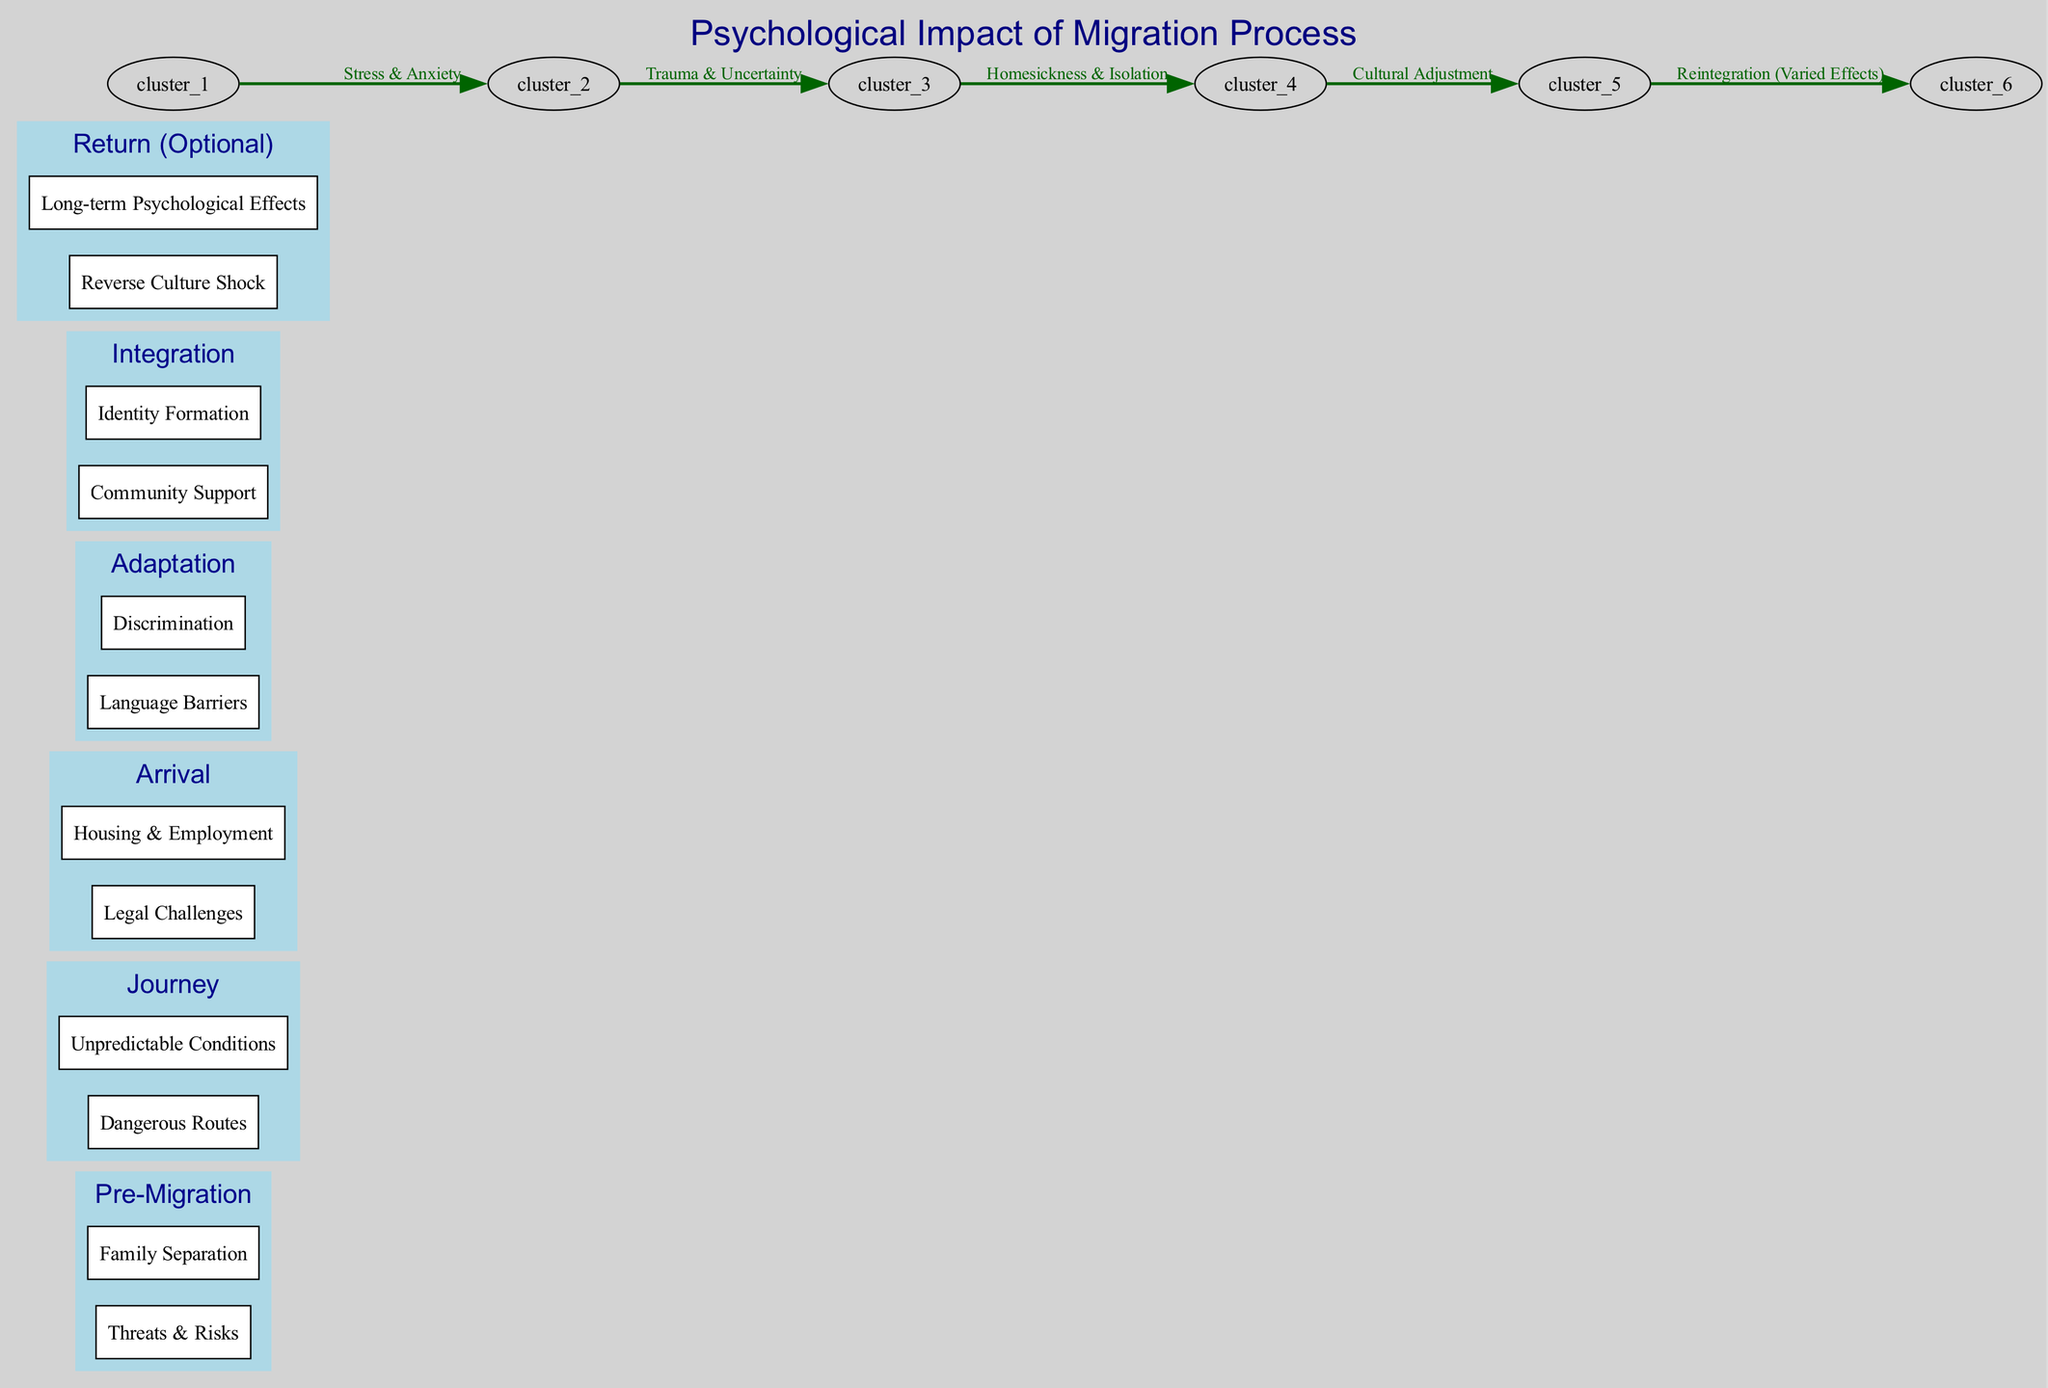What is the title of the diagram? The title is explicitly mentioned at the top of the diagram, which states "Psychological Impact of Migration Process."
Answer: Psychological Impact of Migration Process How many main nodes are in the diagram? By counting the distinct nodes listed in the "nodes" section of the data, there are six main nodes: Pre-Migration, Journey, Arrival, Adaptation, Integration, and Return (Optional).
Answer: 6 What psychological effect is indicated between Pre-Migration and Journey? The edge connecting Pre-Migration and Journey is labeled "Stress & Anxiety," which denotes the psychological effects experienced during this transition.
Answer: Stress & Anxiety Which subnode under Arrival addresses legal issues? The subnode labeled as "Legal Challenges" is present under the parent node of Arrival, indicating concerns related to the legal aspects faced upon arrival.
Answer: Legal Challenges What is the edge label that connects Arrival to Adaptation? The edge going from Arrival to Adaptation is labeled "Homesickness & Isolation," which highlights the psychological challenges during the adaptation stage.
Answer: Homesickness & Isolation How does the Integration stage relate to Return? The edge between Integration and Return (Optional) is labeled "Reintegration (Varied Effects)," signifying that the outcomes of the integration phase can affect the experience of returning.
Answer: Reintegration (Varied Effects) Which subnode indicates feelings of being disconnected from the new environment during Adaptation? The subnode labeled "Discrimination" falls under Adaptation and indicates feelings of being disconnected or marginalized in a new environment.
Answer: Discrimination What are the two subnodes identified under the Journey? Under the Journey node, the two subnodes are "Dangerous Routes" and "Unpredictable Conditions," indicating the challenges faced during the migration journey.
Answer: Dangerous Routes, Unpredictable Conditions Which psychological impact is specifically mentioned in relation to cultural factors during Adaptation? The label "Cultural Adjustment" connects Adaptation to the broader themes of adjusting psychologically to a new cultural environment.
Answer: Cultural Adjustment 